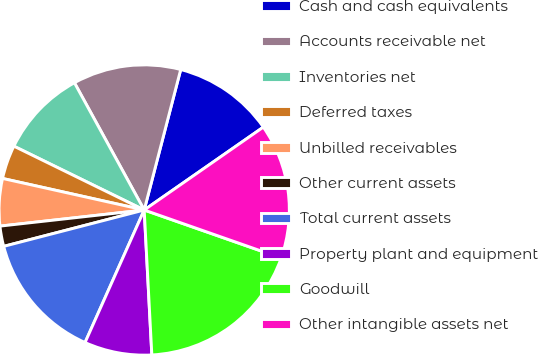Convert chart to OTSL. <chart><loc_0><loc_0><loc_500><loc_500><pie_chart><fcel>Cash and cash equivalents<fcel>Accounts receivable net<fcel>Inventories net<fcel>Deferred taxes<fcel>Unbilled receivables<fcel>Other current assets<fcel>Total current assets<fcel>Property plant and equipment<fcel>Goodwill<fcel>Other intangible assets net<nl><fcel>11.28%<fcel>12.03%<fcel>9.77%<fcel>3.76%<fcel>5.26%<fcel>2.26%<fcel>14.29%<fcel>7.52%<fcel>18.8%<fcel>15.04%<nl></chart> 